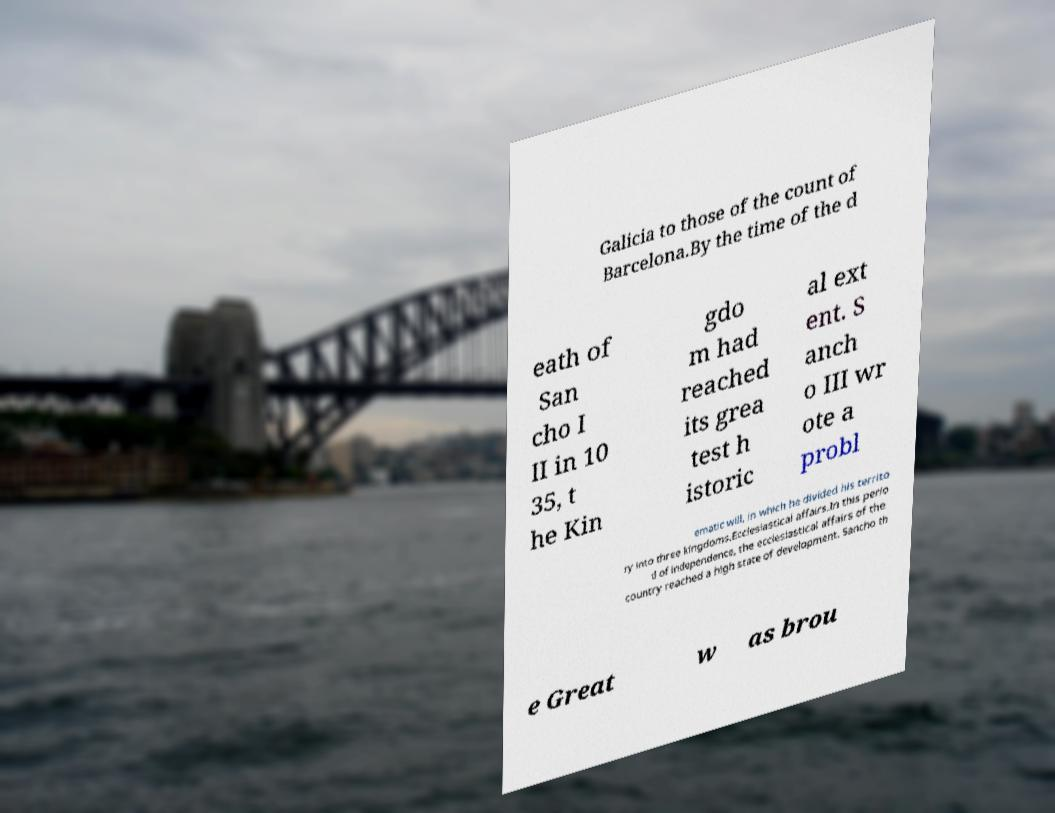Could you assist in decoding the text presented in this image and type it out clearly? Galicia to those of the count of Barcelona.By the time of the d eath of San cho I II in 10 35, t he Kin gdo m had reached its grea test h istoric al ext ent. S anch o III wr ote a probl ematic will, in which he divided his territo ry into three kingdoms.Ecclesiastical affairs.In this perio d of independence, the ecclesiastical affairs of the country reached a high state of development. Sancho th e Great w as brou 